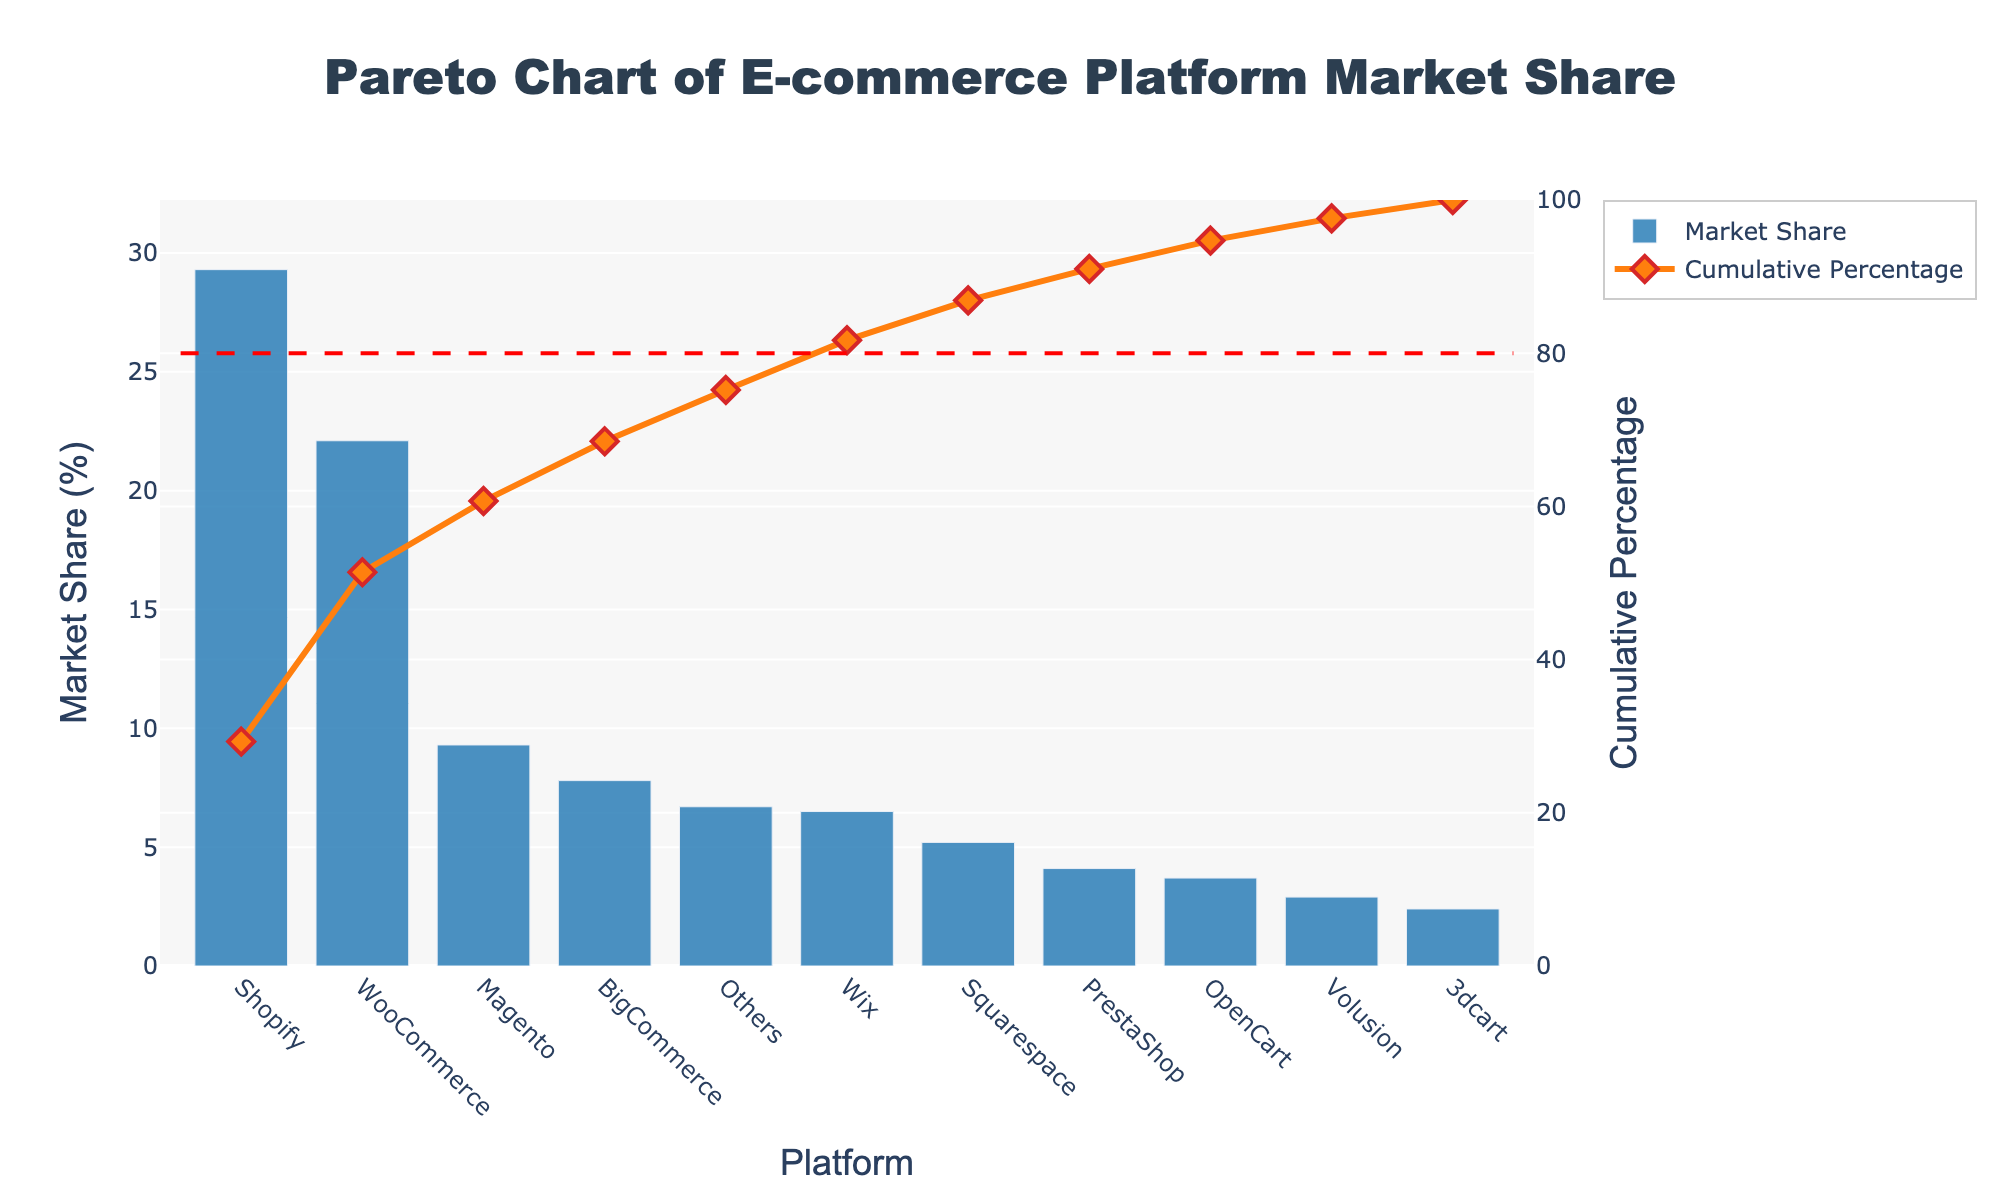What is the title of the chart? The title of the chart is placed at the top of the figure and reads "Pareto Chart of E-commerce Platform Market Share".
Answer: Pareto Chart of E-commerce Platform Market Share Which e-commerce platform has the highest market share? The platform with the highest market share can be easily identified by the tallest bar on the chart, which represents Shopify at 29.3%.
Answer: Shopify What is the cumulative percentage after Wix? The cumulative percentage is displayed on the secondary y-axis (right side) and follows the orange line in the chart. After Wix, the cumulative percentage is at 75.2%.
Answer: 75.2% How many platforms contribute to 80% of the cumulative market share? To determine this, look at the cumulative percentage line and count the number of platforms needed to reach the red dashed line marking 80%. Four platforms (Shopify, WooCommerce, Magento, BigCommerce) are required.
Answer: Four What is the market share difference between WooCommerce and BigCommerce? To find the difference, subtract the market share of BigCommerce (7.8%) from WooCommerce (22.1%). Calculation: 22.1% - 7.8% = 14.3%.
Answer: 14.3% Which platform has the closest market share to PrestaShop? Look at the bars to compare the market share values. OpenCart has a market share of 3.7%, which is closest to PrestaShop's 4.1%.
Answer: OpenCart What is the sum of the market share percentages for Squarespace and Others? Add the market share percentages of Squarespace (5.2%) and Others (6.7%). Calculation: 5.2% + 6.7% = 11.9%.
Answer: 11.9% Which platform contributes the least to the market share? The platform with the shortest bar represents the platform with the least market share, which is 3dcart at 2.4%.
Answer: 3dcart What is the cumulative percentage contributed by the top three platforms? Sum the cumulative percentages in progression: Shopify (29.3%), WooCommerce (22.1%), and Magento (9.3%), giving their cumulative total as 29.3% + 22.1% + 9.3% = 60.7%.
Answer: 60.7% How does the market share of Wix compare to that of Squarespace? Wix has a market share of 6.5%, and Squarespace has a market share of 5.2%. Hence, Wix has a higher market share compared to Squarespace.
Answer: Wix has a higher market share 